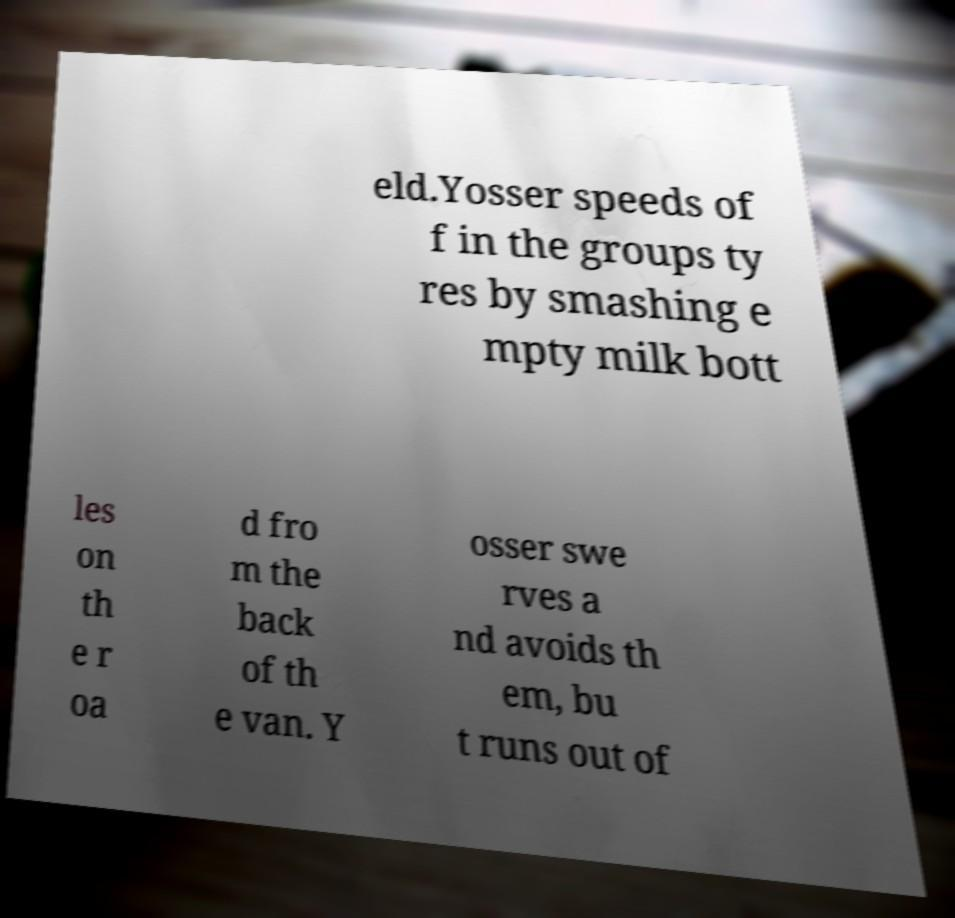There's text embedded in this image that I need extracted. Can you transcribe it verbatim? eld.Yosser speeds of f in the groups ty res by smashing e mpty milk bott les on th e r oa d fro m the back of th e van. Y osser swe rves a nd avoids th em, bu t runs out of 